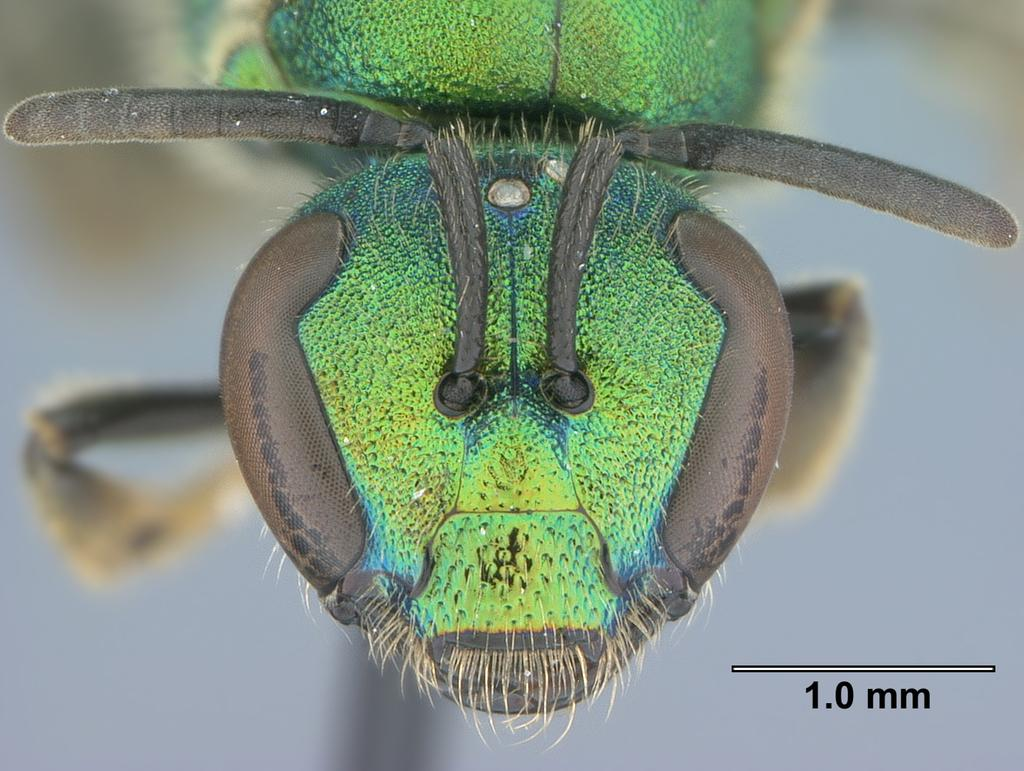What type of creature is present in the image? There is an insect in the image. Can you describe the color of the insect? The insect has green and black color. What type of stem can be seen growing from the insect in the image? There is no stem growing from the insect in the image. How does the tramp interact with the insect in the image? There is no tramp present in the image, so it is not possible to determine how they might interact with the insect. 